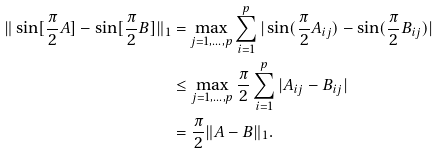Convert formula to latex. <formula><loc_0><loc_0><loc_500><loc_500>\| \sin [ \frac { \pi } { 2 } A ] - \sin [ \frac { \pi } { 2 } B ] \| _ { 1 } & = \max _ { j = 1 , \dots , p } \sum _ { i = 1 } ^ { p } | \sin ( \frac { \pi } { 2 } A _ { i j } ) - \sin ( \frac { \pi } { 2 } B _ { i j } ) | \\ & \leq \max _ { j = 1 , \dots , p } \frac { \pi } { 2 } \sum _ { i = 1 } ^ { p } | A _ { i j } - B _ { i j } | \\ & = \frac { \pi } { 2 } \| A - B \| _ { 1 } .</formula> 